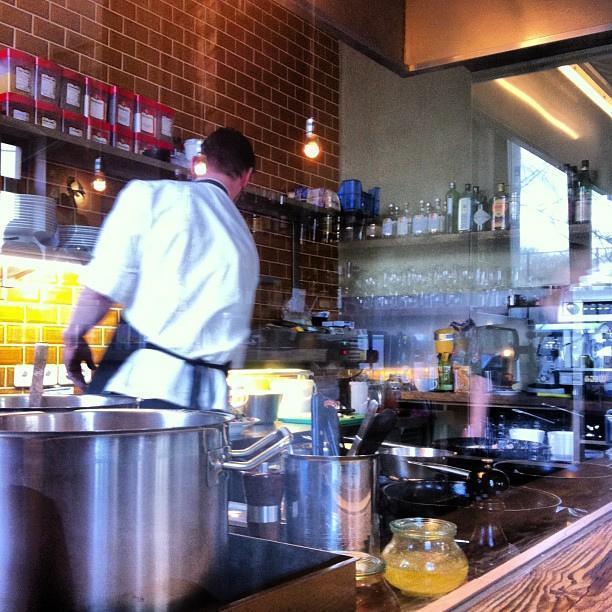What is on the counter?
Select the accurate answer and provide justification: `Answer: choice
Rationale: srationale.`
Options: Cat, pizza pie, dog, pot. Answer: pot.
Rationale: This is a restaurant. there is a metallic item that could be used to boil water. 